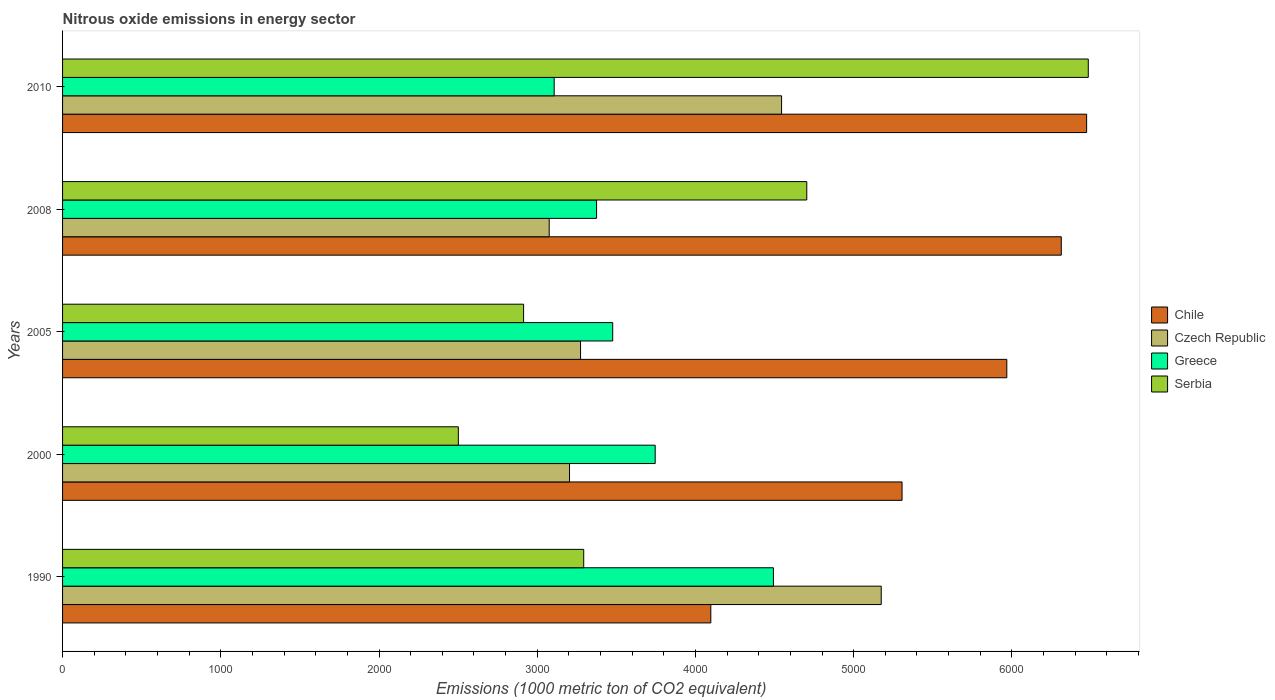How many different coloured bars are there?
Provide a short and direct response. 4. How many groups of bars are there?
Your response must be concise. 5. Are the number of bars per tick equal to the number of legend labels?
Offer a very short reply. Yes. How many bars are there on the 5th tick from the top?
Your response must be concise. 4. What is the label of the 1st group of bars from the top?
Give a very brief answer. 2010. In how many cases, is the number of bars for a given year not equal to the number of legend labels?
Offer a terse response. 0. What is the amount of nitrous oxide emitted in Chile in 2005?
Your answer should be very brief. 5967.8. Across all years, what is the maximum amount of nitrous oxide emitted in Greece?
Make the answer very short. 4492.8. Across all years, what is the minimum amount of nitrous oxide emitted in Greece?
Provide a succinct answer. 3107.1. In which year was the amount of nitrous oxide emitted in Greece minimum?
Offer a terse response. 2010. What is the total amount of nitrous oxide emitted in Serbia in the graph?
Provide a succinct answer. 1.99e+04. What is the difference between the amount of nitrous oxide emitted in Serbia in 2000 and that in 2008?
Offer a very short reply. -2202.2. What is the difference between the amount of nitrous oxide emitted in Chile in 1990 and the amount of nitrous oxide emitted in Serbia in 2008?
Give a very brief answer. -606.6. What is the average amount of nitrous oxide emitted in Chile per year?
Give a very brief answer. 5630.94. In the year 2005, what is the difference between the amount of nitrous oxide emitted in Czech Republic and amount of nitrous oxide emitted in Greece?
Offer a terse response. -203.3. What is the ratio of the amount of nitrous oxide emitted in Greece in 1990 to that in 2010?
Offer a very short reply. 1.45. Is the difference between the amount of nitrous oxide emitted in Czech Republic in 1990 and 2005 greater than the difference between the amount of nitrous oxide emitted in Greece in 1990 and 2005?
Offer a very short reply. Yes. What is the difference between the highest and the second highest amount of nitrous oxide emitted in Serbia?
Keep it short and to the point. 1779.1. What is the difference between the highest and the lowest amount of nitrous oxide emitted in Chile?
Make the answer very short. 2375.2. What does the 4th bar from the bottom in 2008 represents?
Offer a very short reply. Serbia. How many years are there in the graph?
Your answer should be very brief. 5. Does the graph contain grids?
Provide a succinct answer. No. Where does the legend appear in the graph?
Provide a succinct answer. Center right. How many legend labels are there?
Give a very brief answer. 4. How are the legend labels stacked?
Make the answer very short. Vertical. What is the title of the graph?
Provide a short and direct response. Nitrous oxide emissions in energy sector. Does "Swaziland" appear as one of the legend labels in the graph?
Your answer should be compact. No. What is the label or title of the X-axis?
Ensure brevity in your answer.  Emissions (1000 metric ton of CO2 equivalent). What is the Emissions (1000 metric ton of CO2 equivalent) of Chile in 1990?
Offer a terse response. 4097. What is the Emissions (1000 metric ton of CO2 equivalent) of Czech Republic in 1990?
Offer a very short reply. 5174.1. What is the Emissions (1000 metric ton of CO2 equivalent) of Greece in 1990?
Your answer should be compact. 4492.8. What is the Emissions (1000 metric ton of CO2 equivalent) of Serbia in 1990?
Provide a short and direct response. 3293.8. What is the Emissions (1000 metric ton of CO2 equivalent) of Chile in 2000?
Offer a very short reply. 5305.7. What is the Emissions (1000 metric ton of CO2 equivalent) in Czech Republic in 2000?
Provide a succinct answer. 3204.1. What is the Emissions (1000 metric ton of CO2 equivalent) of Greece in 2000?
Provide a succinct answer. 3745.5. What is the Emissions (1000 metric ton of CO2 equivalent) of Serbia in 2000?
Your answer should be compact. 2501.4. What is the Emissions (1000 metric ton of CO2 equivalent) of Chile in 2005?
Your answer should be very brief. 5967.8. What is the Emissions (1000 metric ton of CO2 equivalent) of Czech Republic in 2005?
Offer a terse response. 3273.7. What is the Emissions (1000 metric ton of CO2 equivalent) in Greece in 2005?
Provide a succinct answer. 3477. What is the Emissions (1000 metric ton of CO2 equivalent) in Serbia in 2005?
Your response must be concise. 2913.8. What is the Emissions (1000 metric ton of CO2 equivalent) of Chile in 2008?
Offer a terse response. 6312. What is the Emissions (1000 metric ton of CO2 equivalent) in Czech Republic in 2008?
Ensure brevity in your answer.  3075.6. What is the Emissions (1000 metric ton of CO2 equivalent) in Greece in 2008?
Your answer should be very brief. 3375. What is the Emissions (1000 metric ton of CO2 equivalent) in Serbia in 2008?
Your answer should be compact. 4703.6. What is the Emissions (1000 metric ton of CO2 equivalent) in Chile in 2010?
Provide a short and direct response. 6472.2. What is the Emissions (1000 metric ton of CO2 equivalent) of Czech Republic in 2010?
Your response must be concise. 4544.3. What is the Emissions (1000 metric ton of CO2 equivalent) of Greece in 2010?
Your response must be concise. 3107.1. What is the Emissions (1000 metric ton of CO2 equivalent) in Serbia in 2010?
Keep it short and to the point. 6482.7. Across all years, what is the maximum Emissions (1000 metric ton of CO2 equivalent) of Chile?
Offer a very short reply. 6472.2. Across all years, what is the maximum Emissions (1000 metric ton of CO2 equivalent) in Czech Republic?
Your answer should be very brief. 5174.1. Across all years, what is the maximum Emissions (1000 metric ton of CO2 equivalent) in Greece?
Offer a very short reply. 4492.8. Across all years, what is the maximum Emissions (1000 metric ton of CO2 equivalent) of Serbia?
Keep it short and to the point. 6482.7. Across all years, what is the minimum Emissions (1000 metric ton of CO2 equivalent) in Chile?
Your response must be concise. 4097. Across all years, what is the minimum Emissions (1000 metric ton of CO2 equivalent) of Czech Republic?
Offer a terse response. 3075.6. Across all years, what is the minimum Emissions (1000 metric ton of CO2 equivalent) of Greece?
Keep it short and to the point. 3107.1. Across all years, what is the minimum Emissions (1000 metric ton of CO2 equivalent) of Serbia?
Provide a short and direct response. 2501.4. What is the total Emissions (1000 metric ton of CO2 equivalent) of Chile in the graph?
Ensure brevity in your answer.  2.82e+04. What is the total Emissions (1000 metric ton of CO2 equivalent) in Czech Republic in the graph?
Make the answer very short. 1.93e+04. What is the total Emissions (1000 metric ton of CO2 equivalent) of Greece in the graph?
Offer a terse response. 1.82e+04. What is the total Emissions (1000 metric ton of CO2 equivalent) of Serbia in the graph?
Make the answer very short. 1.99e+04. What is the difference between the Emissions (1000 metric ton of CO2 equivalent) of Chile in 1990 and that in 2000?
Your answer should be compact. -1208.7. What is the difference between the Emissions (1000 metric ton of CO2 equivalent) of Czech Republic in 1990 and that in 2000?
Your answer should be very brief. 1970. What is the difference between the Emissions (1000 metric ton of CO2 equivalent) in Greece in 1990 and that in 2000?
Your response must be concise. 747.3. What is the difference between the Emissions (1000 metric ton of CO2 equivalent) in Serbia in 1990 and that in 2000?
Offer a very short reply. 792.4. What is the difference between the Emissions (1000 metric ton of CO2 equivalent) in Chile in 1990 and that in 2005?
Your answer should be compact. -1870.8. What is the difference between the Emissions (1000 metric ton of CO2 equivalent) in Czech Republic in 1990 and that in 2005?
Your answer should be very brief. 1900.4. What is the difference between the Emissions (1000 metric ton of CO2 equivalent) of Greece in 1990 and that in 2005?
Your answer should be compact. 1015.8. What is the difference between the Emissions (1000 metric ton of CO2 equivalent) in Serbia in 1990 and that in 2005?
Ensure brevity in your answer.  380. What is the difference between the Emissions (1000 metric ton of CO2 equivalent) in Chile in 1990 and that in 2008?
Your answer should be compact. -2215. What is the difference between the Emissions (1000 metric ton of CO2 equivalent) in Czech Republic in 1990 and that in 2008?
Offer a terse response. 2098.5. What is the difference between the Emissions (1000 metric ton of CO2 equivalent) of Greece in 1990 and that in 2008?
Your response must be concise. 1117.8. What is the difference between the Emissions (1000 metric ton of CO2 equivalent) of Serbia in 1990 and that in 2008?
Offer a terse response. -1409.8. What is the difference between the Emissions (1000 metric ton of CO2 equivalent) in Chile in 1990 and that in 2010?
Your response must be concise. -2375.2. What is the difference between the Emissions (1000 metric ton of CO2 equivalent) in Czech Republic in 1990 and that in 2010?
Make the answer very short. 629.8. What is the difference between the Emissions (1000 metric ton of CO2 equivalent) in Greece in 1990 and that in 2010?
Ensure brevity in your answer.  1385.7. What is the difference between the Emissions (1000 metric ton of CO2 equivalent) of Serbia in 1990 and that in 2010?
Offer a very short reply. -3188.9. What is the difference between the Emissions (1000 metric ton of CO2 equivalent) in Chile in 2000 and that in 2005?
Your response must be concise. -662.1. What is the difference between the Emissions (1000 metric ton of CO2 equivalent) of Czech Republic in 2000 and that in 2005?
Make the answer very short. -69.6. What is the difference between the Emissions (1000 metric ton of CO2 equivalent) of Greece in 2000 and that in 2005?
Your response must be concise. 268.5. What is the difference between the Emissions (1000 metric ton of CO2 equivalent) of Serbia in 2000 and that in 2005?
Give a very brief answer. -412.4. What is the difference between the Emissions (1000 metric ton of CO2 equivalent) of Chile in 2000 and that in 2008?
Ensure brevity in your answer.  -1006.3. What is the difference between the Emissions (1000 metric ton of CO2 equivalent) of Czech Republic in 2000 and that in 2008?
Ensure brevity in your answer.  128.5. What is the difference between the Emissions (1000 metric ton of CO2 equivalent) in Greece in 2000 and that in 2008?
Offer a terse response. 370.5. What is the difference between the Emissions (1000 metric ton of CO2 equivalent) in Serbia in 2000 and that in 2008?
Provide a short and direct response. -2202.2. What is the difference between the Emissions (1000 metric ton of CO2 equivalent) of Chile in 2000 and that in 2010?
Give a very brief answer. -1166.5. What is the difference between the Emissions (1000 metric ton of CO2 equivalent) in Czech Republic in 2000 and that in 2010?
Offer a terse response. -1340.2. What is the difference between the Emissions (1000 metric ton of CO2 equivalent) in Greece in 2000 and that in 2010?
Provide a short and direct response. 638.4. What is the difference between the Emissions (1000 metric ton of CO2 equivalent) in Serbia in 2000 and that in 2010?
Provide a succinct answer. -3981.3. What is the difference between the Emissions (1000 metric ton of CO2 equivalent) of Chile in 2005 and that in 2008?
Offer a terse response. -344.2. What is the difference between the Emissions (1000 metric ton of CO2 equivalent) of Czech Republic in 2005 and that in 2008?
Give a very brief answer. 198.1. What is the difference between the Emissions (1000 metric ton of CO2 equivalent) of Greece in 2005 and that in 2008?
Your response must be concise. 102. What is the difference between the Emissions (1000 metric ton of CO2 equivalent) of Serbia in 2005 and that in 2008?
Your answer should be very brief. -1789.8. What is the difference between the Emissions (1000 metric ton of CO2 equivalent) of Chile in 2005 and that in 2010?
Offer a very short reply. -504.4. What is the difference between the Emissions (1000 metric ton of CO2 equivalent) in Czech Republic in 2005 and that in 2010?
Ensure brevity in your answer.  -1270.6. What is the difference between the Emissions (1000 metric ton of CO2 equivalent) in Greece in 2005 and that in 2010?
Give a very brief answer. 369.9. What is the difference between the Emissions (1000 metric ton of CO2 equivalent) in Serbia in 2005 and that in 2010?
Provide a succinct answer. -3568.9. What is the difference between the Emissions (1000 metric ton of CO2 equivalent) of Chile in 2008 and that in 2010?
Provide a succinct answer. -160.2. What is the difference between the Emissions (1000 metric ton of CO2 equivalent) of Czech Republic in 2008 and that in 2010?
Offer a terse response. -1468.7. What is the difference between the Emissions (1000 metric ton of CO2 equivalent) of Greece in 2008 and that in 2010?
Offer a terse response. 267.9. What is the difference between the Emissions (1000 metric ton of CO2 equivalent) of Serbia in 2008 and that in 2010?
Keep it short and to the point. -1779.1. What is the difference between the Emissions (1000 metric ton of CO2 equivalent) of Chile in 1990 and the Emissions (1000 metric ton of CO2 equivalent) of Czech Republic in 2000?
Make the answer very short. 892.9. What is the difference between the Emissions (1000 metric ton of CO2 equivalent) in Chile in 1990 and the Emissions (1000 metric ton of CO2 equivalent) in Greece in 2000?
Give a very brief answer. 351.5. What is the difference between the Emissions (1000 metric ton of CO2 equivalent) of Chile in 1990 and the Emissions (1000 metric ton of CO2 equivalent) of Serbia in 2000?
Your answer should be very brief. 1595.6. What is the difference between the Emissions (1000 metric ton of CO2 equivalent) of Czech Republic in 1990 and the Emissions (1000 metric ton of CO2 equivalent) of Greece in 2000?
Give a very brief answer. 1428.6. What is the difference between the Emissions (1000 metric ton of CO2 equivalent) of Czech Republic in 1990 and the Emissions (1000 metric ton of CO2 equivalent) of Serbia in 2000?
Ensure brevity in your answer.  2672.7. What is the difference between the Emissions (1000 metric ton of CO2 equivalent) of Greece in 1990 and the Emissions (1000 metric ton of CO2 equivalent) of Serbia in 2000?
Keep it short and to the point. 1991.4. What is the difference between the Emissions (1000 metric ton of CO2 equivalent) of Chile in 1990 and the Emissions (1000 metric ton of CO2 equivalent) of Czech Republic in 2005?
Your response must be concise. 823.3. What is the difference between the Emissions (1000 metric ton of CO2 equivalent) of Chile in 1990 and the Emissions (1000 metric ton of CO2 equivalent) of Greece in 2005?
Give a very brief answer. 620. What is the difference between the Emissions (1000 metric ton of CO2 equivalent) in Chile in 1990 and the Emissions (1000 metric ton of CO2 equivalent) in Serbia in 2005?
Ensure brevity in your answer.  1183.2. What is the difference between the Emissions (1000 metric ton of CO2 equivalent) of Czech Republic in 1990 and the Emissions (1000 metric ton of CO2 equivalent) of Greece in 2005?
Ensure brevity in your answer.  1697.1. What is the difference between the Emissions (1000 metric ton of CO2 equivalent) in Czech Republic in 1990 and the Emissions (1000 metric ton of CO2 equivalent) in Serbia in 2005?
Provide a succinct answer. 2260.3. What is the difference between the Emissions (1000 metric ton of CO2 equivalent) in Greece in 1990 and the Emissions (1000 metric ton of CO2 equivalent) in Serbia in 2005?
Provide a short and direct response. 1579. What is the difference between the Emissions (1000 metric ton of CO2 equivalent) in Chile in 1990 and the Emissions (1000 metric ton of CO2 equivalent) in Czech Republic in 2008?
Give a very brief answer. 1021.4. What is the difference between the Emissions (1000 metric ton of CO2 equivalent) in Chile in 1990 and the Emissions (1000 metric ton of CO2 equivalent) in Greece in 2008?
Keep it short and to the point. 722. What is the difference between the Emissions (1000 metric ton of CO2 equivalent) of Chile in 1990 and the Emissions (1000 metric ton of CO2 equivalent) of Serbia in 2008?
Your response must be concise. -606.6. What is the difference between the Emissions (1000 metric ton of CO2 equivalent) in Czech Republic in 1990 and the Emissions (1000 metric ton of CO2 equivalent) in Greece in 2008?
Provide a succinct answer. 1799.1. What is the difference between the Emissions (1000 metric ton of CO2 equivalent) of Czech Republic in 1990 and the Emissions (1000 metric ton of CO2 equivalent) of Serbia in 2008?
Keep it short and to the point. 470.5. What is the difference between the Emissions (1000 metric ton of CO2 equivalent) of Greece in 1990 and the Emissions (1000 metric ton of CO2 equivalent) of Serbia in 2008?
Give a very brief answer. -210.8. What is the difference between the Emissions (1000 metric ton of CO2 equivalent) of Chile in 1990 and the Emissions (1000 metric ton of CO2 equivalent) of Czech Republic in 2010?
Offer a terse response. -447.3. What is the difference between the Emissions (1000 metric ton of CO2 equivalent) of Chile in 1990 and the Emissions (1000 metric ton of CO2 equivalent) of Greece in 2010?
Your response must be concise. 989.9. What is the difference between the Emissions (1000 metric ton of CO2 equivalent) of Chile in 1990 and the Emissions (1000 metric ton of CO2 equivalent) of Serbia in 2010?
Offer a terse response. -2385.7. What is the difference between the Emissions (1000 metric ton of CO2 equivalent) in Czech Republic in 1990 and the Emissions (1000 metric ton of CO2 equivalent) in Greece in 2010?
Keep it short and to the point. 2067. What is the difference between the Emissions (1000 metric ton of CO2 equivalent) in Czech Republic in 1990 and the Emissions (1000 metric ton of CO2 equivalent) in Serbia in 2010?
Ensure brevity in your answer.  -1308.6. What is the difference between the Emissions (1000 metric ton of CO2 equivalent) in Greece in 1990 and the Emissions (1000 metric ton of CO2 equivalent) in Serbia in 2010?
Provide a succinct answer. -1989.9. What is the difference between the Emissions (1000 metric ton of CO2 equivalent) in Chile in 2000 and the Emissions (1000 metric ton of CO2 equivalent) in Czech Republic in 2005?
Give a very brief answer. 2032. What is the difference between the Emissions (1000 metric ton of CO2 equivalent) in Chile in 2000 and the Emissions (1000 metric ton of CO2 equivalent) in Greece in 2005?
Offer a very short reply. 1828.7. What is the difference between the Emissions (1000 metric ton of CO2 equivalent) in Chile in 2000 and the Emissions (1000 metric ton of CO2 equivalent) in Serbia in 2005?
Offer a very short reply. 2391.9. What is the difference between the Emissions (1000 metric ton of CO2 equivalent) in Czech Republic in 2000 and the Emissions (1000 metric ton of CO2 equivalent) in Greece in 2005?
Keep it short and to the point. -272.9. What is the difference between the Emissions (1000 metric ton of CO2 equivalent) of Czech Republic in 2000 and the Emissions (1000 metric ton of CO2 equivalent) of Serbia in 2005?
Your answer should be very brief. 290.3. What is the difference between the Emissions (1000 metric ton of CO2 equivalent) of Greece in 2000 and the Emissions (1000 metric ton of CO2 equivalent) of Serbia in 2005?
Give a very brief answer. 831.7. What is the difference between the Emissions (1000 metric ton of CO2 equivalent) in Chile in 2000 and the Emissions (1000 metric ton of CO2 equivalent) in Czech Republic in 2008?
Offer a terse response. 2230.1. What is the difference between the Emissions (1000 metric ton of CO2 equivalent) in Chile in 2000 and the Emissions (1000 metric ton of CO2 equivalent) in Greece in 2008?
Your answer should be compact. 1930.7. What is the difference between the Emissions (1000 metric ton of CO2 equivalent) of Chile in 2000 and the Emissions (1000 metric ton of CO2 equivalent) of Serbia in 2008?
Give a very brief answer. 602.1. What is the difference between the Emissions (1000 metric ton of CO2 equivalent) of Czech Republic in 2000 and the Emissions (1000 metric ton of CO2 equivalent) of Greece in 2008?
Ensure brevity in your answer.  -170.9. What is the difference between the Emissions (1000 metric ton of CO2 equivalent) of Czech Republic in 2000 and the Emissions (1000 metric ton of CO2 equivalent) of Serbia in 2008?
Provide a short and direct response. -1499.5. What is the difference between the Emissions (1000 metric ton of CO2 equivalent) of Greece in 2000 and the Emissions (1000 metric ton of CO2 equivalent) of Serbia in 2008?
Ensure brevity in your answer.  -958.1. What is the difference between the Emissions (1000 metric ton of CO2 equivalent) of Chile in 2000 and the Emissions (1000 metric ton of CO2 equivalent) of Czech Republic in 2010?
Your answer should be very brief. 761.4. What is the difference between the Emissions (1000 metric ton of CO2 equivalent) of Chile in 2000 and the Emissions (1000 metric ton of CO2 equivalent) of Greece in 2010?
Offer a terse response. 2198.6. What is the difference between the Emissions (1000 metric ton of CO2 equivalent) of Chile in 2000 and the Emissions (1000 metric ton of CO2 equivalent) of Serbia in 2010?
Ensure brevity in your answer.  -1177. What is the difference between the Emissions (1000 metric ton of CO2 equivalent) in Czech Republic in 2000 and the Emissions (1000 metric ton of CO2 equivalent) in Greece in 2010?
Offer a very short reply. 97. What is the difference between the Emissions (1000 metric ton of CO2 equivalent) of Czech Republic in 2000 and the Emissions (1000 metric ton of CO2 equivalent) of Serbia in 2010?
Offer a terse response. -3278.6. What is the difference between the Emissions (1000 metric ton of CO2 equivalent) in Greece in 2000 and the Emissions (1000 metric ton of CO2 equivalent) in Serbia in 2010?
Offer a very short reply. -2737.2. What is the difference between the Emissions (1000 metric ton of CO2 equivalent) of Chile in 2005 and the Emissions (1000 metric ton of CO2 equivalent) of Czech Republic in 2008?
Provide a short and direct response. 2892.2. What is the difference between the Emissions (1000 metric ton of CO2 equivalent) of Chile in 2005 and the Emissions (1000 metric ton of CO2 equivalent) of Greece in 2008?
Provide a succinct answer. 2592.8. What is the difference between the Emissions (1000 metric ton of CO2 equivalent) of Chile in 2005 and the Emissions (1000 metric ton of CO2 equivalent) of Serbia in 2008?
Provide a short and direct response. 1264.2. What is the difference between the Emissions (1000 metric ton of CO2 equivalent) of Czech Republic in 2005 and the Emissions (1000 metric ton of CO2 equivalent) of Greece in 2008?
Ensure brevity in your answer.  -101.3. What is the difference between the Emissions (1000 metric ton of CO2 equivalent) in Czech Republic in 2005 and the Emissions (1000 metric ton of CO2 equivalent) in Serbia in 2008?
Keep it short and to the point. -1429.9. What is the difference between the Emissions (1000 metric ton of CO2 equivalent) of Greece in 2005 and the Emissions (1000 metric ton of CO2 equivalent) of Serbia in 2008?
Provide a short and direct response. -1226.6. What is the difference between the Emissions (1000 metric ton of CO2 equivalent) in Chile in 2005 and the Emissions (1000 metric ton of CO2 equivalent) in Czech Republic in 2010?
Your answer should be compact. 1423.5. What is the difference between the Emissions (1000 metric ton of CO2 equivalent) of Chile in 2005 and the Emissions (1000 metric ton of CO2 equivalent) of Greece in 2010?
Provide a short and direct response. 2860.7. What is the difference between the Emissions (1000 metric ton of CO2 equivalent) in Chile in 2005 and the Emissions (1000 metric ton of CO2 equivalent) in Serbia in 2010?
Offer a terse response. -514.9. What is the difference between the Emissions (1000 metric ton of CO2 equivalent) in Czech Republic in 2005 and the Emissions (1000 metric ton of CO2 equivalent) in Greece in 2010?
Ensure brevity in your answer.  166.6. What is the difference between the Emissions (1000 metric ton of CO2 equivalent) in Czech Republic in 2005 and the Emissions (1000 metric ton of CO2 equivalent) in Serbia in 2010?
Provide a short and direct response. -3209. What is the difference between the Emissions (1000 metric ton of CO2 equivalent) of Greece in 2005 and the Emissions (1000 metric ton of CO2 equivalent) of Serbia in 2010?
Your response must be concise. -3005.7. What is the difference between the Emissions (1000 metric ton of CO2 equivalent) in Chile in 2008 and the Emissions (1000 metric ton of CO2 equivalent) in Czech Republic in 2010?
Keep it short and to the point. 1767.7. What is the difference between the Emissions (1000 metric ton of CO2 equivalent) of Chile in 2008 and the Emissions (1000 metric ton of CO2 equivalent) of Greece in 2010?
Provide a succinct answer. 3204.9. What is the difference between the Emissions (1000 metric ton of CO2 equivalent) in Chile in 2008 and the Emissions (1000 metric ton of CO2 equivalent) in Serbia in 2010?
Offer a very short reply. -170.7. What is the difference between the Emissions (1000 metric ton of CO2 equivalent) in Czech Republic in 2008 and the Emissions (1000 metric ton of CO2 equivalent) in Greece in 2010?
Provide a succinct answer. -31.5. What is the difference between the Emissions (1000 metric ton of CO2 equivalent) in Czech Republic in 2008 and the Emissions (1000 metric ton of CO2 equivalent) in Serbia in 2010?
Your answer should be compact. -3407.1. What is the difference between the Emissions (1000 metric ton of CO2 equivalent) in Greece in 2008 and the Emissions (1000 metric ton of CO2 equivalent) in Serbia in 2010?
Keep it short and to the point. -3107.7. What is the average Emissions (1000 metric ton of CO2 equivalent) in Chile per year?
Offer a very short reply. 5630.94. What is the average Emissions (1000 metric ton of CO2 equivalent) in Czech Republic per year?
Your response must be concise. 3854.36. What is the average Emissions (1000 metric ton of CO2 equivalent) of Greece per year?
Give a very brief answer. 3639.48. What is the average Emissions (1000 metric ton of CO2 equivalent) of Serbia per year?
Provide a succinct answer. 3979.06. In the year 1990, what is the difference between the Emissions (1000 metric ton of CO2 equivalent) in Chile and Emissions (1000 metric ton of CO2 equivalent) in Czech Republic?
Make the answer very short. -1077.1. In the year 1990, what is the difference between the Emissions (1000 metric ton of CO2 equivalent) in Chile and Emissions (1000 metric ton of CO2 equivalent) in Greece?
Offer a terse response. -395.8. In the year 1990, what is the difference between the Emissions (1000 metric ton of CO2 equivalent) in Chile and Emissions (1000 metric ton of CO2 equivalent) in Serbia?
Make the answer very short. 803.2. In the year 1990, what is the difference between the Emissions (1000 metric ton of CO2 equivalent) in Czech Republic and Emissions (1000 metric ton of CO2 equivalent) in Greece?
Give a very brief answer. 681.3. In the year 1990, what is the difference between the Emissions (1000 metric ton of CO2 equivalent) of Czech Republic and Emissions (1000 metric ton of CO2 equivalent) of Serbia?
Offer a very short reply. 1880.3. In the year 1990, what is the difference between the Emissions (1000 metric ton of CO2 equivalent) of Greece and Emissions (1000 metric ton of CO2 equivalent) of Serbia?
Keep it short and to the point. 1199. In the year 2000, what is the difference between the Emissions (1000 metric ton of CO2 equivalent) of Chile and Emissions (1000 metric ton of CO2 equivalent) of Czech Republic?
Offer a terse response. 2101.6. In the year 2000, what is the difference between the Emissions (1000 metric ton of CO2 equivalent) in Chile and Emissions (1000 metric ton of CO2 equivalent) in Greece?
Your answer should be compact. 1560.2. In the year 2000, what is the difference between the Emissions (1000 metric ton of CO2 equivalent) in Chile and Emissions (1000 metric ton of CO2 equivalent) in Serbia?
Your answer should be very brief. 2804.3. In the year 2000, what is the difference between the Emissions (1000 metric ton of CO2 equivalent) of Czech Republic and Emissions (1000 metric ton of CO2 equivalent) of Greece?
Ensure brevity in your answer.  -541.4. In the year 2000, what is the difference between the Emissions (1000 metric ton of CO2 equivalent) of Czech Republic and Emissions (1000 metric ton of CO2 equivalent) of Serbia?
Give a very brief answer. 702.7. In the year 2000, what is the difference between the Emissions (1000 metric ton of CO2 equivalent) of Greece and Emissions (1000 metric ton of CO2 equivalent) of Serbia?
Your response must be concise. 1244.1. In the year 2005, what is the difference between the Emissions (1000 metric ton of CO2 equivalent) of Chile and Emissions (1000 metric ton of CO2 equivalent) of Czech Republic?
Make the answer very short. 2694.1. In the year 2005, what is the difference between the Emissions (1000 metric ton of CO2 equivalent) of Chile and Emissions (1000 metric ton of CO2 equivalent) of Greece?
Ensure brevity in your answer.  2490.8. In the year 2005, what is the difference between the Emissions (1000 metric ton of CO2 equivalent) of Chile and Emissions (1000 metric ton of CO2 equivalent) of Serbia?
Offer a terse response. 3054. In the year 2005, what is the difference between the Emissions (1000 metric ton of CO2 equivalent) in Czech Republic and Emissions (1000 metric ton of CO2 equivalent) in Greece?
Ensure brevity in your answer.  -203.3. In the year 2005, what is the difference between the Emissions (1000 metric ton of CO2 equivalent) of Czech Republic and Emissions (1000 metric ton of CO2 equivalent) of Serbia?
Offer a terse response. 359.9. In the year 2005, what is the difference between the Emissions (1000 metric ton of CO2 equivalent) in Greece and Emissions (1000 metric ton of CO2 equivalent) in Serbia?
Offer a terse response. 563.2. In the year 2008, what is the difference between the Emissions (1000 metric ton of CO2 equivalent) in Chile and Emissions (1000 metric ton of CO2 equivalent) in Czech Republic?
Your response must be concise. 3236.4. In the year 2008, what is the difference between the Emissions (1000 metric ton of CO2 equivalent) of Chile and Emissions (1000 metric ton of CO2 equivalent) of Greece?
Make the answer very short. 2937. In the year 2008, what is the difference between the Emissions (1000 metric ton of CO2 equivalent) of Chile and Emissions (1000 metric ton of CO2 equivalent) of Serbia?
Give a very brief answer. 1608.4. In the year 2008, what is the difference between the Emissions (1000 metric ton of CO2 equivalent) of Czech Republic and Emissions (1000 metric ton of CO2 equivalent) of Greece?
Your answer should be very brief. -299.4. In the year 2008, what is the difference between the Emissions (1000 metric ton of CO2 equivalent) in Czech Republic and Emissions (1000 metric ton of CO2 equivalent) in Serbia?
Your answer should be very brief. -1628. In the year 2008, what is the difference between the Emissions (1000 metric ton of CO2 equivalent) of Greece and Emissions (1000 metric ton of CO2 equivalent) of Serbia?
Give a very brief answer. -1328.6. In the year 2010, what is the difference between the Emissions (1000 metric ton of CO2 equivalent) of Chile and Emissions (1000 metric ton of CO2 equivalent) of Czech Republic?
Offer a terse response. 1927.9. In the year 2010, what is the difference between the Emissions (1000 metric ton of CO2 equivalent) of Chile and Emissions (1000 metric ton of CO2 equivalent) of Greece?
Offer a very short reply. 3365.1. In the year 2010, what is the difference between the Emissions (1000 metric ton of CO2 equivalent) of Czech Republic and Emissions (1000 metric ton of CO2 equivalent) of Greece?
Ensure brevity in your answer.  1437.2. In the year 2010, what is the difference between the Emissions (1000 metric ton of CO2 equivalent) of Czech Republic and Emissions (1000 metric ton of CO2 equivalent) of Serbia?
Keep it short and to the point. -1938.4. In the year 2010, what is the difference between the Emissions (1000 metric ton of CO2 equivalent) of Greece and Emissions (1000 metric ton of CO2 equivalent) of Serbia?
Give a very brief answer. -3375.6. What is the ratio of the Emissions (1000 metric ton of CO2 equivalent) of Chile in 1990 to that in 2000?
Your response must be concise. 0.77. What is the ratio of the Emissions (1000 metric ton of CO2 equivalent) in Czech Republic in 1990 to that in 2000?
Your answer should be compact. 1.61. What is the ratio of the Emissions (1000 metric ton of CO2 equivalent) of Greece in 1990 to that in 2000?
Provide a short and direct response. 1.2. What is the ratio of the Emissions (1000 metric ton of CO2 equivalent) in Serbia in 1990 to that in 2000?
Ensure brevity in your answer.  1.32. What is the ratio of the Emissions (1000 metric ton of CO2 equivalent) of Chile in 1990 to that in 2005?
Your response must be concise. 0.69. What is the ratio of the Emissions (1000 metric ton of CO2 equivalent) of Czech Republic in 1990 to that in 2005?
Your response must be concise. 1.58. What is the ratio of the Emissions (1000 metric ton of CO2 equivalent) in Greece in 1990 to that in 2005?
Make the answer very short. 1.29. What is the ratio of the Emissions (1000 metric ton of CO2 equivalent) in Serbia in 1990 to that in 2005?
Your answer should be compact. 1.13. What is the ratio of the Emissions (1000 metric ton of CO2 equivalent) of Chile in 1990 to that in 2008?
Your answer should be compact. 0.65. What is the ratio of the Emissions (1000 metric ton of CO2 equivalent) in Czech Republic in 1990 to that in 2008?
Offer a terse response. 1.68. What is the ratio of the Emissions (1000 metric ton of CO2 equivalent) of Greece in 1990 to that in 2008?
Offer a terse response. 1.33. What is the ratio of the Emissions (1000 metric ton of CO2 equivalent) in Serbia in 1990 to that in 2008?
Make the answer very short. 0.7. What is the ratio of the Emissions (1000 metric ton of CO2 equivalent) in Chile in 1990 to that in 2010?
Offer a terse response. 0.63. What is the ratio of the Emissions (1000 metric ton of CO2 equivalent) in Czech Republic in 1990 to that in 2010?
Offer a terse response. 1.14. What is the ratio of the Emissions (1000 metric ton of CO2 equivalent) in Greece in 1990 to that in 2010?
Keep it short and to the point. 1.45. What is the ratio of the Emissions (1000 metric ton of CO2 equivalent) in Serbia in 1990 to that in 2010?
Provide a succinct answer. 0.51. What is the ratio of the Emissions (1000 metric ton of CO2 equivalent) of Chile in 2000 to that in 2005?
Offer a terse response. 0.89. What is the ratio of the Emissions (1000 metric ton of CO2 equivalent) in Czech Republic in 2000 to that in 2005?
Give a very brief answer. 0.98. What is the ratio of the Emissions (1000 metric ton of CO2 equivalent) of Greece in 2000 to that in 2005?
Offer a very short reply. 1.08. What is the ratio of the Emissions (1000 metric ton of CO2 equivalent) of Serbia in 2000 to that in 2005?
Offer a very short reply. 0.86. What is the ratio of the Emissions (1000 metric ton of CO2 equivalent) of Chile in 2000 to that in 2008?
Provide a succinct answer. 0.84. What is the ratio of the Emissions (1000 metric ton of CO2 equivalent) in Czech Republic in 2000 to that in 2008?
Keep it short and to the point. 1.04. What is the ratio of the Emissions (1000 metric ton of CO2 equivalent) of Greece in 2000 to that in 2008?
Make the answer very short. 1.11. What is the ratio of the Emissions (1000 metric ton of CO2 equivalent) of Serbia in 2000 to that in 2008?
Keep it short and to the point. 0.53. What is the ratio of the Emissions (1000 metric ton of CO2 equivalent) of Chile in 2000 to that in 2010?
Ensure brevity in your answer.  0.82. What is the ratio of the Emissions (1000 metric ton of CO2 equivalent) in Czech Republic in 2000 to that in 2010?
Your response must be concise. 0.71. What is the ratio of the Emissions (1000 metric ton of CO2 equivalent) of Greece in 2000 to that in 2010?
Your answer should be very brief. 1.21. What is the ratio of the Emissions (1000 metric ton of CO2 equivalent) in Serbia in 2000 to that in 2010?
Your response must be concise. 0.39. What is the ratio of the Emissions (1000 metric ton of CO2 equivalent) in Chile in 2005 to that in 2008?
Keep it short and to the point. 0.95. What is the ratio of the Emissions (1000 metric ton of CO2 equivalent) in Czech Republic in 2005 to that in 2008?
Give a very brief answer. 1.06. What is the ratio of the Emissions (1000 metric ton of CO2 equivalent) in Greece in 2005 to that in 2008?
Provide a short and direct response. 1.03. What is the ratio of the Emissions (1000 metric ton of CO2 equivalent) of Serbia in 2005 to that in 2008?
Make the answer very short. 0.62. What is the ratio of the Emissions (1000 metric ton of CO2 equivalent) in Chile in 2005 to that in 2010?
Your answer should be very brief. 0.92. What is the ratio of the Emissions (1000 metric ton of CO2 equivalent) in Czech Republic in 2005 to that in 2010?
Make the answer very short. 0.72. What is the ratio of the Emissions (1000 metric ton of CO2 equivalent) of Greece in 2005 to that in 2010?
Your response must be concise. 1.12. What is the ratio of the Emissions (1000 metric ton of CO2 equivalent) in Serbia in 2005 to that in 2010?
Offer a very short reply. 0.45. What is the ratio of the Emissions (1000 metric ton of CO2 equivalent) of Chile in 2008 to that in 2010?
Make the answer very short. 0.98. What is the ratio of the Emissions (1000 metric ton of CO2 equivalent) of Czech Republic in 2008 to that in 2010?
Provide a short and direct response. 0.68. What is the ratio of the Emissions (1000 metric ton of CO2 equivalent) of Greece in 2008 to that in 2010?
Your answer should be very brief. 1.09. What is the ratio of the Emissions (1000 metric ton of CO2 equivalent) of Serbia in 2008 to that in 2010?
Provide a succinct answer. 0.73. What is the difference between the highest and the second highest Emissions (1000 metric ton of CO2 equivalent) in Chile?
Give a very brief answer. 160.2. What is the difference between the highest and the second highest Emissions (1000 metric ton of CO2 equivalent) of Czech Republic?
Your answer should be compact. 629.8. What is the difference between the highest and the second highest Emissions (1000 metric ton of CO2 equivalent) in Greece?
Give a very brief answer. 747.3. What is the difference between the highest and the second highest Emissions (1000 metric ton of CO2 equivalent) of Serbia?
Provide a succinct answer. 1779.1. What is the difference between the highest and the lowest Emissions (1000 metric ton of CO2 equivalent) in Chile?
Offer a terse response. 2375.2. What is the difference between the highest and the lowest Emissions (1000 metric ton of CO2 equivalent) of Czech Republic?
Keep it short and to the point. 2098.5. What is the difference between the highest and the lowest Emissions (1000 metric ton of CO2 equivalent) in Greece?
Offer a terse response. 1385.7. What is the difference between the highest and the lowest Emissions (1000 metric ton of CO2 equivalent) of Serbia?
Your answer should be very brief. 3981.3. 